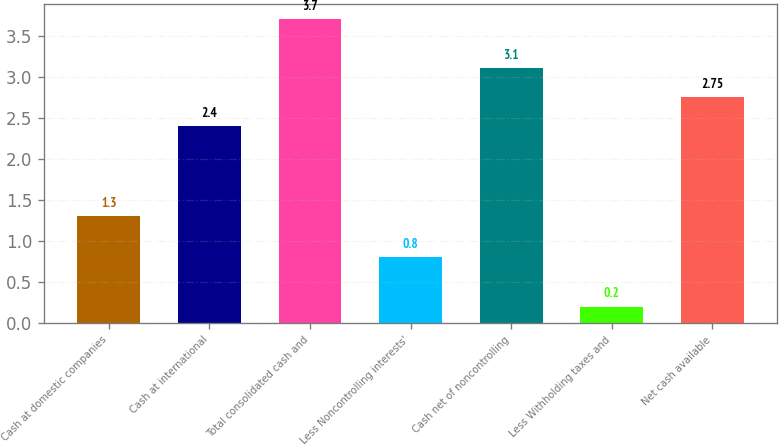Convert chart to OTSL. <chart><loc_0><loc_0><loc_500><loc_500><bar_chart><fcel>Cash at domestic companies<fcel>Cash at international<fcel>Total consolidated cash and<fcel>Less Noncontrolling interests'<fcel>Cash net of noncontrolling<fcel>Less Withholding taxes and<fcel>Net cash available<nl><fcel>1.3<fcel>2.4<fcel>3.7<fcel>0.8<fcel>3.1<fcel>0.2<fcel>2.75<nl></chart> 